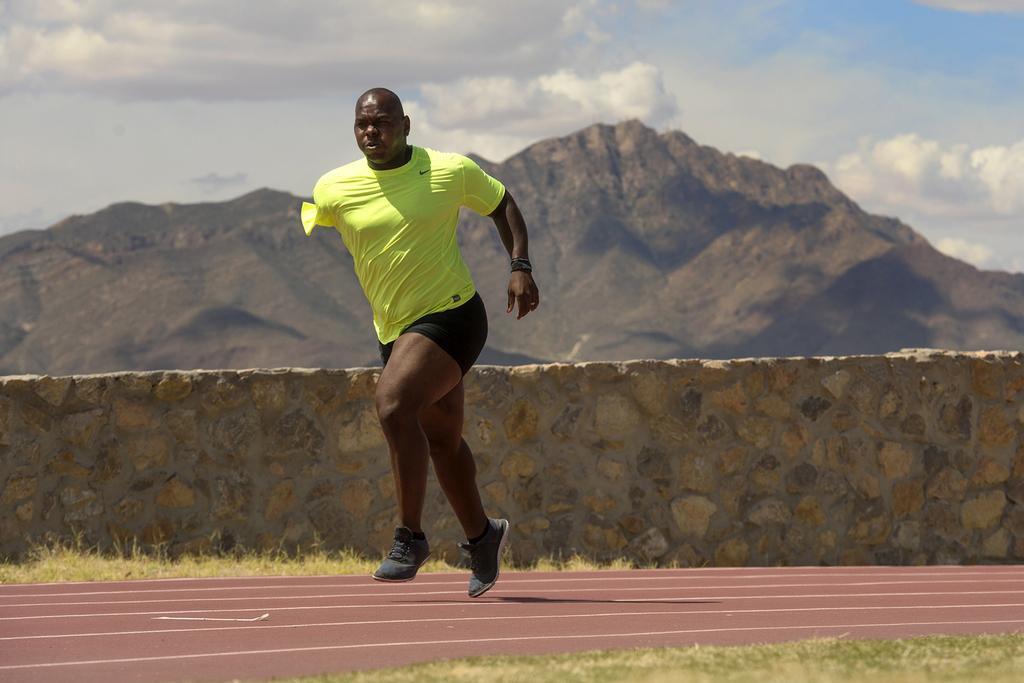Describe this image in one or two sentences. In this picture there is a man, with one hand in the center of the image he is running and there is a small wall behind him and there are mountains in the background area of the image. 